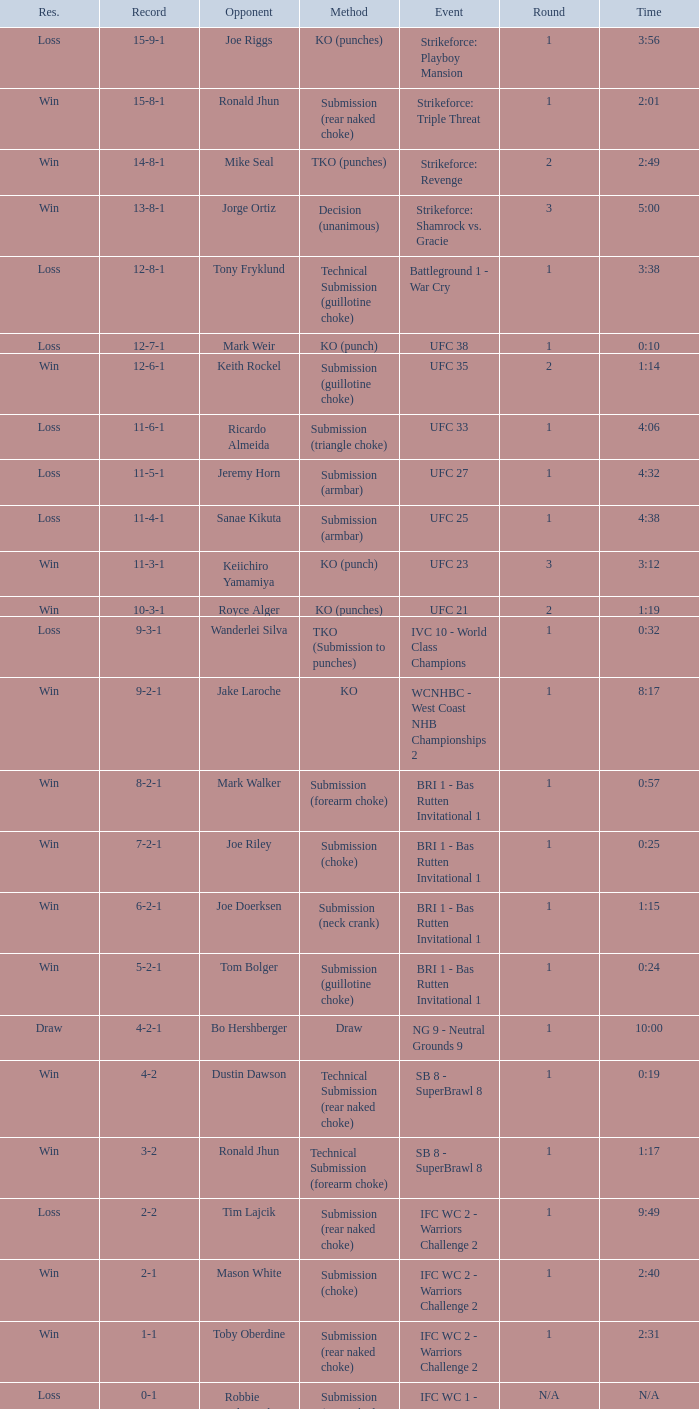What is the record during the event, UFC 27? 11-5-1. 